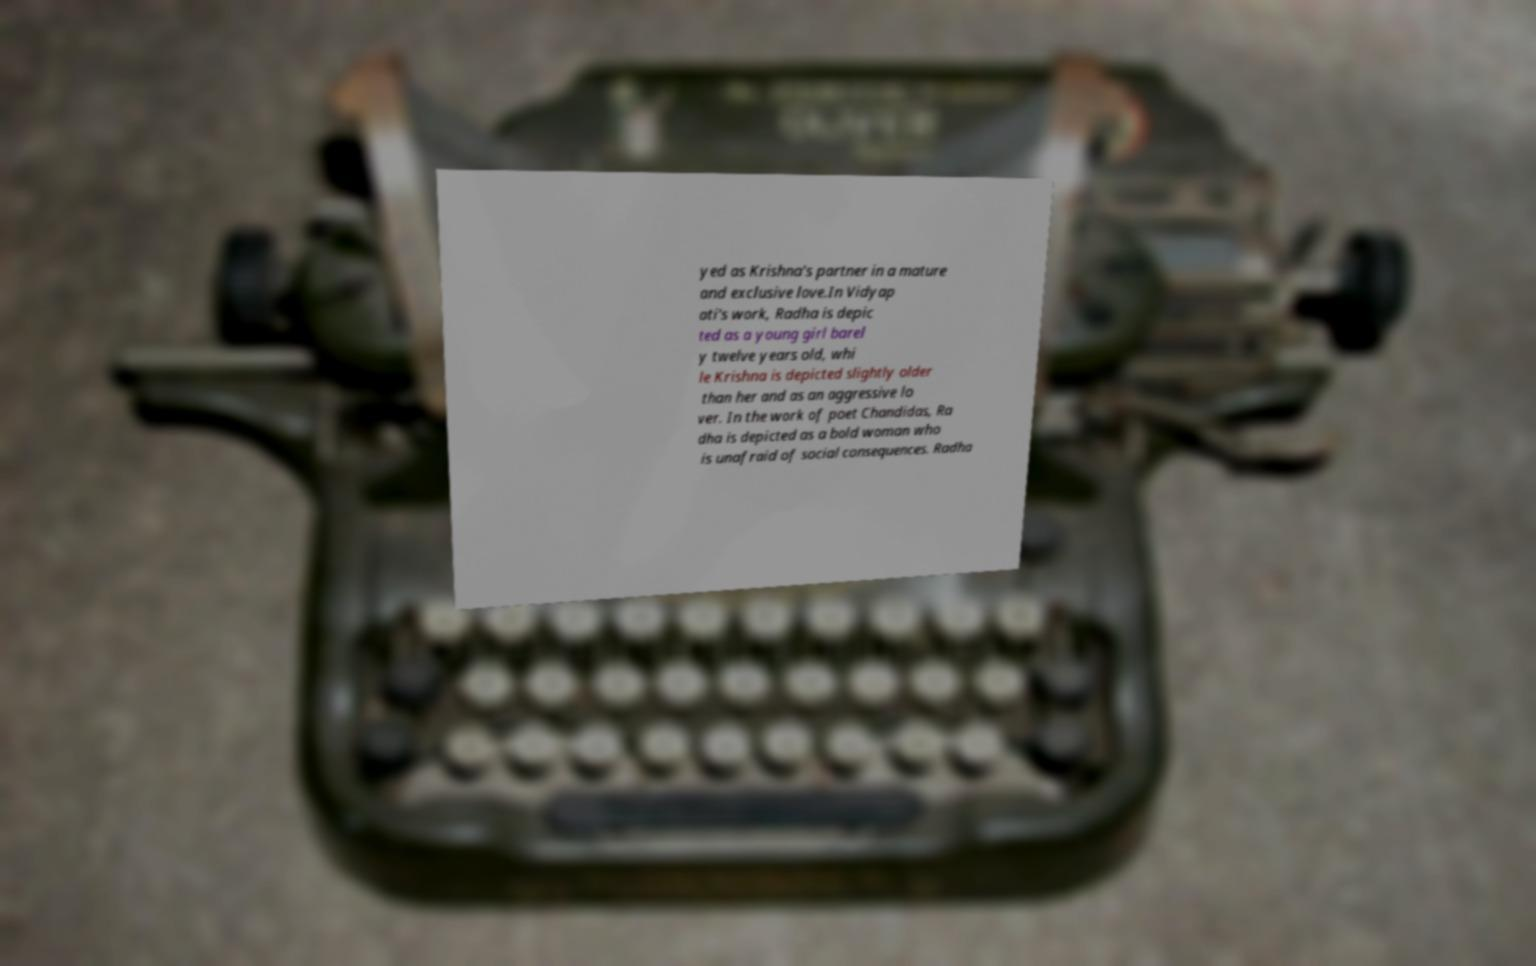Could you assist in decoding the text presented in this image and type it out clearly? yed as Krishna's partner in a mature and exclusive love.In Vidyap ati's work, Radha is depic ted as a young girl barel y twelve years old, whi le Krishna is depicted slightly older than her and as an aggressive lo ver. In the work of poet Chandidas, Ra dha is depicted as a bold woman who is unafraid of social consequences. Radha 